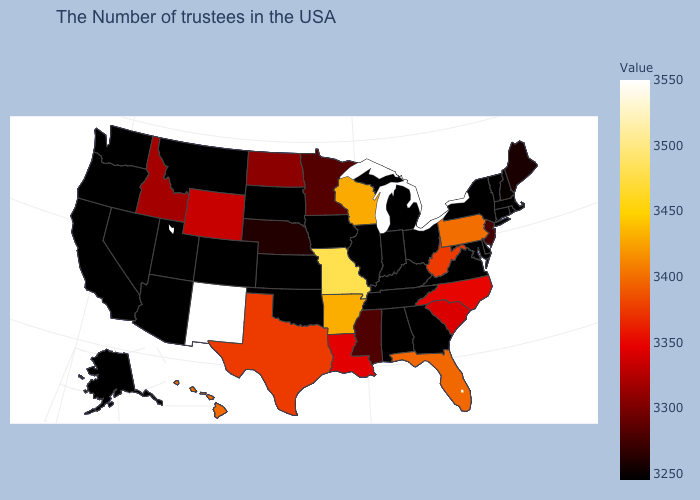Which states hav the highest value in the West?
Write a very short answer. New Mexico. Among the states that border Arizona , does New Mexico have the lowest value?
Give a very brief answer. No. Does New York have the lowest value in the USA?
Give a very brief answer. Yes. 